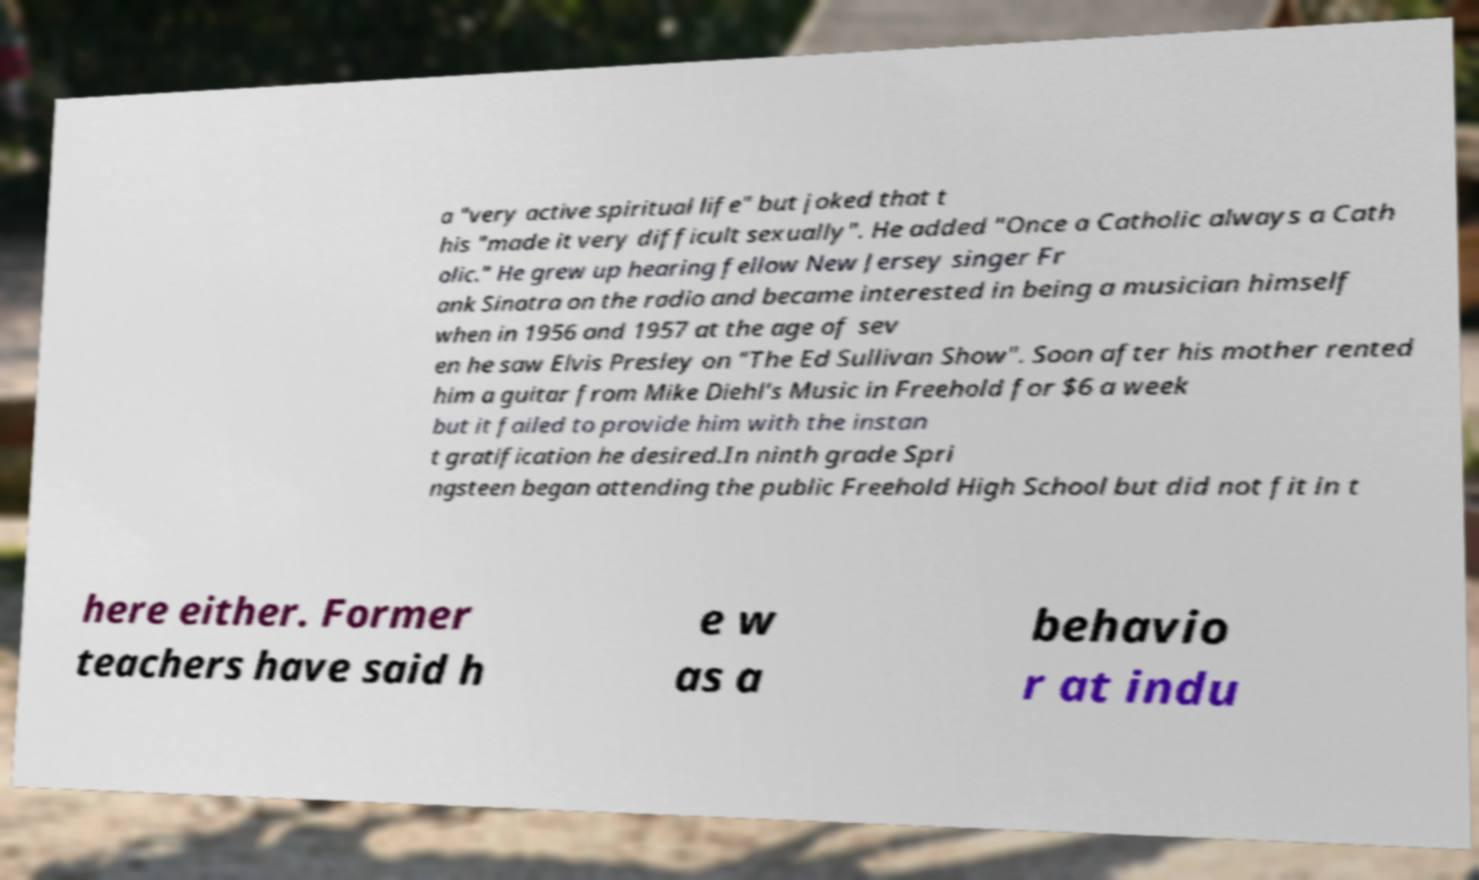Can you read and provide the text displayed in the image?This photo seems to have some interesting text. Can you extract and type it out for me? a "very active spiritual life" but joked that t his "made it very difficult sexually". He added "Once a Catholic always a Cath olic." He grew up hearing fellow New Jersey singer Fr ank Sinatra on the radio and became interested in being a musician himself when in 1956 and 1957 at the age of sev en he saw Elvis Presley on "The Ed Sullivan Show". Soon after his mother rented him a guitar from Mike Diehl's Music in Freehold for $6 a week but it failed to provide him with the instan t gratification he desired.In ninth grade Spri ngsteen began attending the public Freehold High School but did not fit in t here either. Former teachers have said h e w as a behavio r at indu 